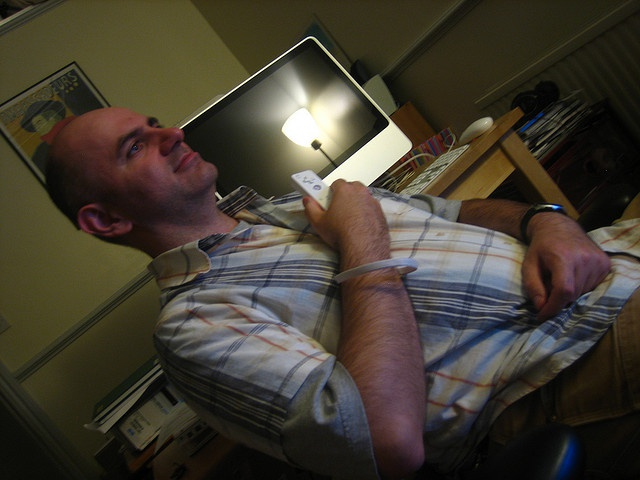Describe the objects in this image and their specific colors. I can see people in black, gray, maroon, and darkgray tones, tv in black, beige, gray, and darkgreen tones, book in black, darkgreen, gray, and navy tones, book in black, darkgreen, and gray tones, and keyboard in black, gray, darkgreen, and darkgray tones in this image. 